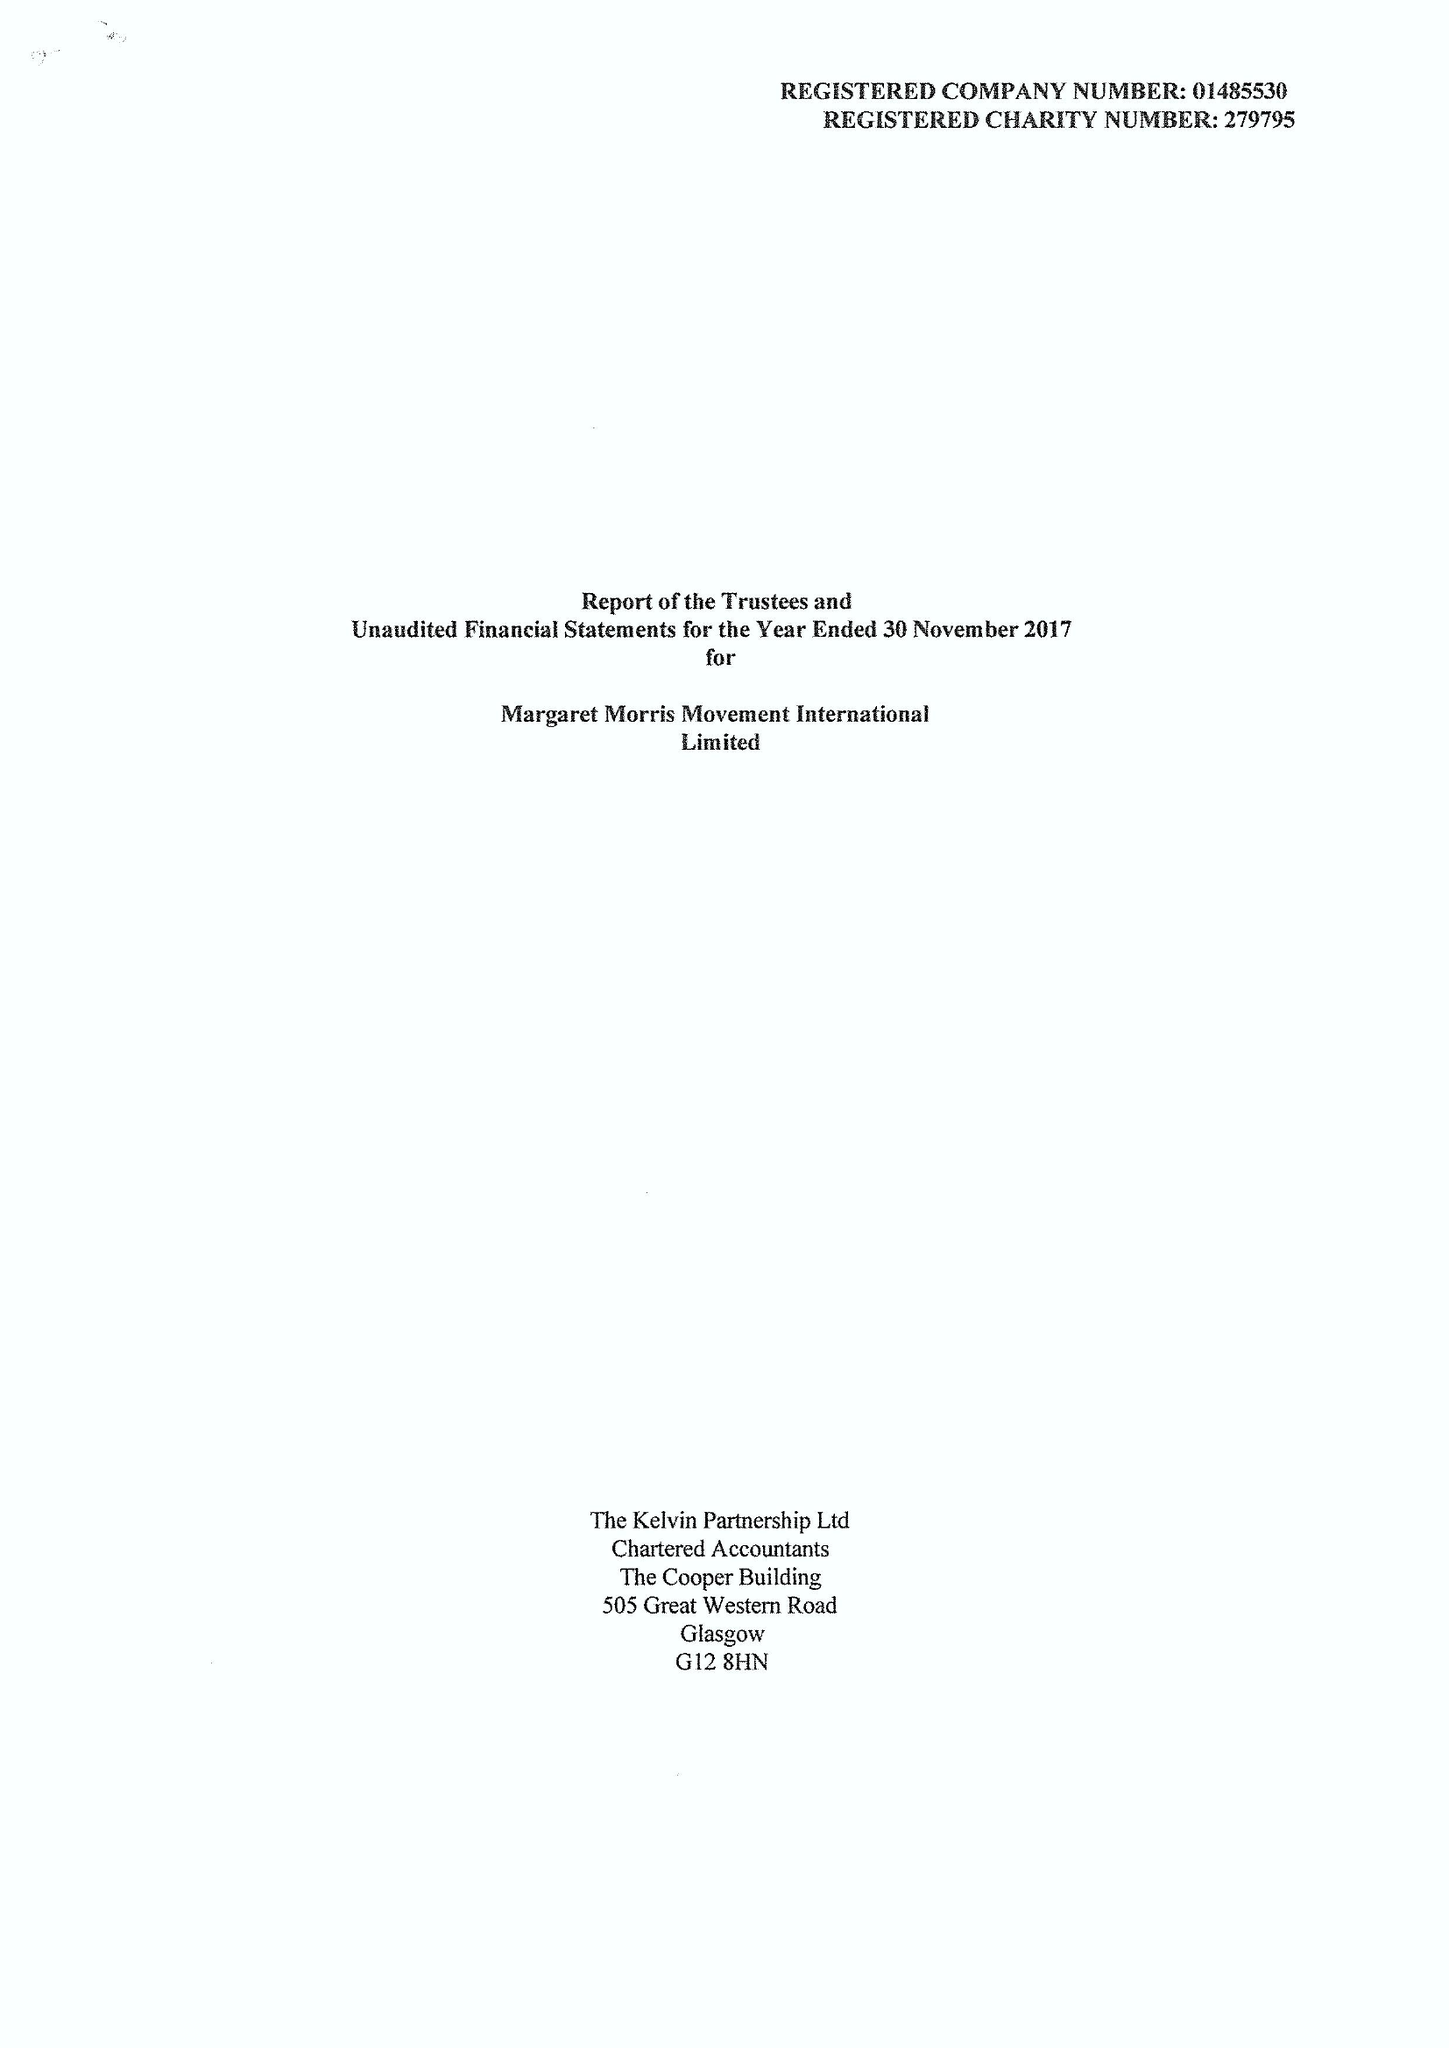What is the value for the income_annually_in_british_pounds?
Answer the question using a single word or phrase. 61842.00 